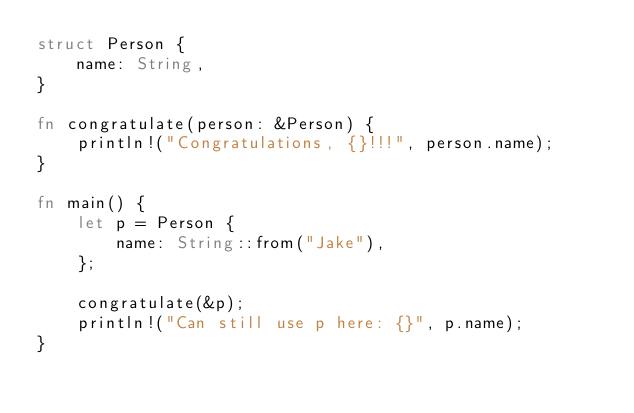<code> <loc_0><loc_0><loc_500><loc_500><_Rust_>struct Person {
    name: String,
}

fn congratulate(person: &Person) {
    println!("Congratulations, {}!!!", person.name);
}

fn main() {
    let p = Person {
        name: String::from("Jake"),
    };

    congratulate(&p);
    println!("Can still use p here: {}", p.name);
}
</code> 